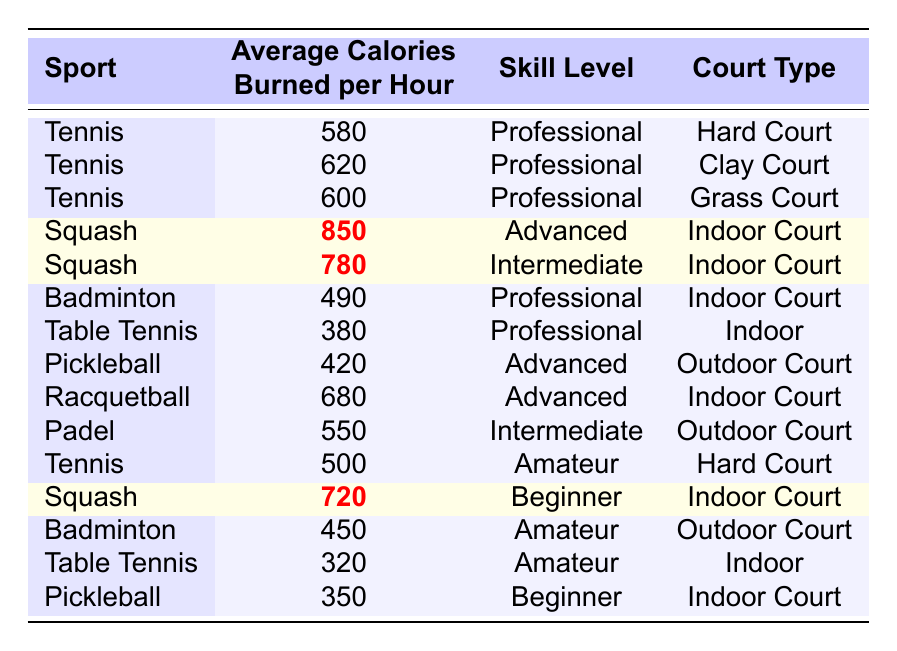What sport has the highest average calories burned per hour? Looking at the table, the sport with the highest average calories burned per hour is Squash with 850 calories.
Answer: Squash What is the average calorie burn for tennis across all skill levels and court types? To find the average calorie burn for tennis, we first list the calorie values: 580, 620, 600, and 500. Adding these gives 580 + 620 + 600 + 500 = 2300, and there are 4 values, so we divide 2300 by 4 to get 575.
Answer: 575 Is Racquetball at a professional skill level? In the table, Racquetball has an Advanced skill level listed, which is not Professional.
Answer: No How many calories does an Advanced level player burn in Pickleball compared to Squash? Pickleball has an Advanced level burn rate of 420 calories, while Squash has a higher burn rate at 850 calories. The difference is 850 - 420 = 430 calories.
Answer: 430 Which sport for beginners burns the most calories? The table shows that Squash for beginners burns 720 calories, and the only other sport for beginners is Pickleball, which burns 350 calories. Therefore, Squash is the highest.
Answer: Squash What is the total number of calories burned per hour for Intermediate level players across all sports listed? The table lists two Intermediate level entries: Squash (780 calories) and Padel (550 calories). Adding these together gives 780 + 550 = 1330 calories.
Answer: 1330 Does Badminton have a higher calorie burn than Table Tennis across all skill levels? Badminton burns 490 and 450 calories for Professional and Amateur levels, respectively. Table Tennis burns 380 and 320 calories for Professional and Amateur levels. Both Badminton values are higher than both Table Tennis values.
Answer: Yes What percentage of the calorie burn for tennis on a Clay Court (620) is compared to that of Squash at the Advanced level (850)? To find the percentage, we calculate (620 / 850) * 100. This equals approximately 72.94%.
Answer: 72.94% Which sport has a wider range of calorie burn when comparing all skill levels? Tennis shows a range from 500 to 620 calories (= 120 range), while Squash shows a range from 720 to 850 calories (= 130 range). Squash's range is wider since 130 is greater than 120.
Answer: Squash If someone plays Padel and Badminton at the Intermediate level, what is their total calorie burn per hour? The table shows Padel burns 550 calories at Intermediate, while Badminton burns 490 calories at a Professional level. Adding these gives 550 + 490 = 1040 calories total for both sports.
Answer: 1040 